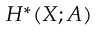Convert formula to latex. <formula><loc_0><loc_0><loc_500><loc_500>H ^ { * } ( X ; A )</formula> 